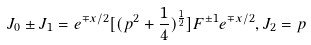<formula> <loc_0><loc_0><loc_500><loc_500>J _ { 0 } \pm J _ { 1 } = e ^ { \mp x / 2 } [ ( p ^ { 2 } + \frac { 1 } { 4 } ) ^ { \frac { 1 } { 2 } } ] F ^ { \pm 1 } e ^ { \mp x / 2 } , J _ { 2 } = p</formula> 